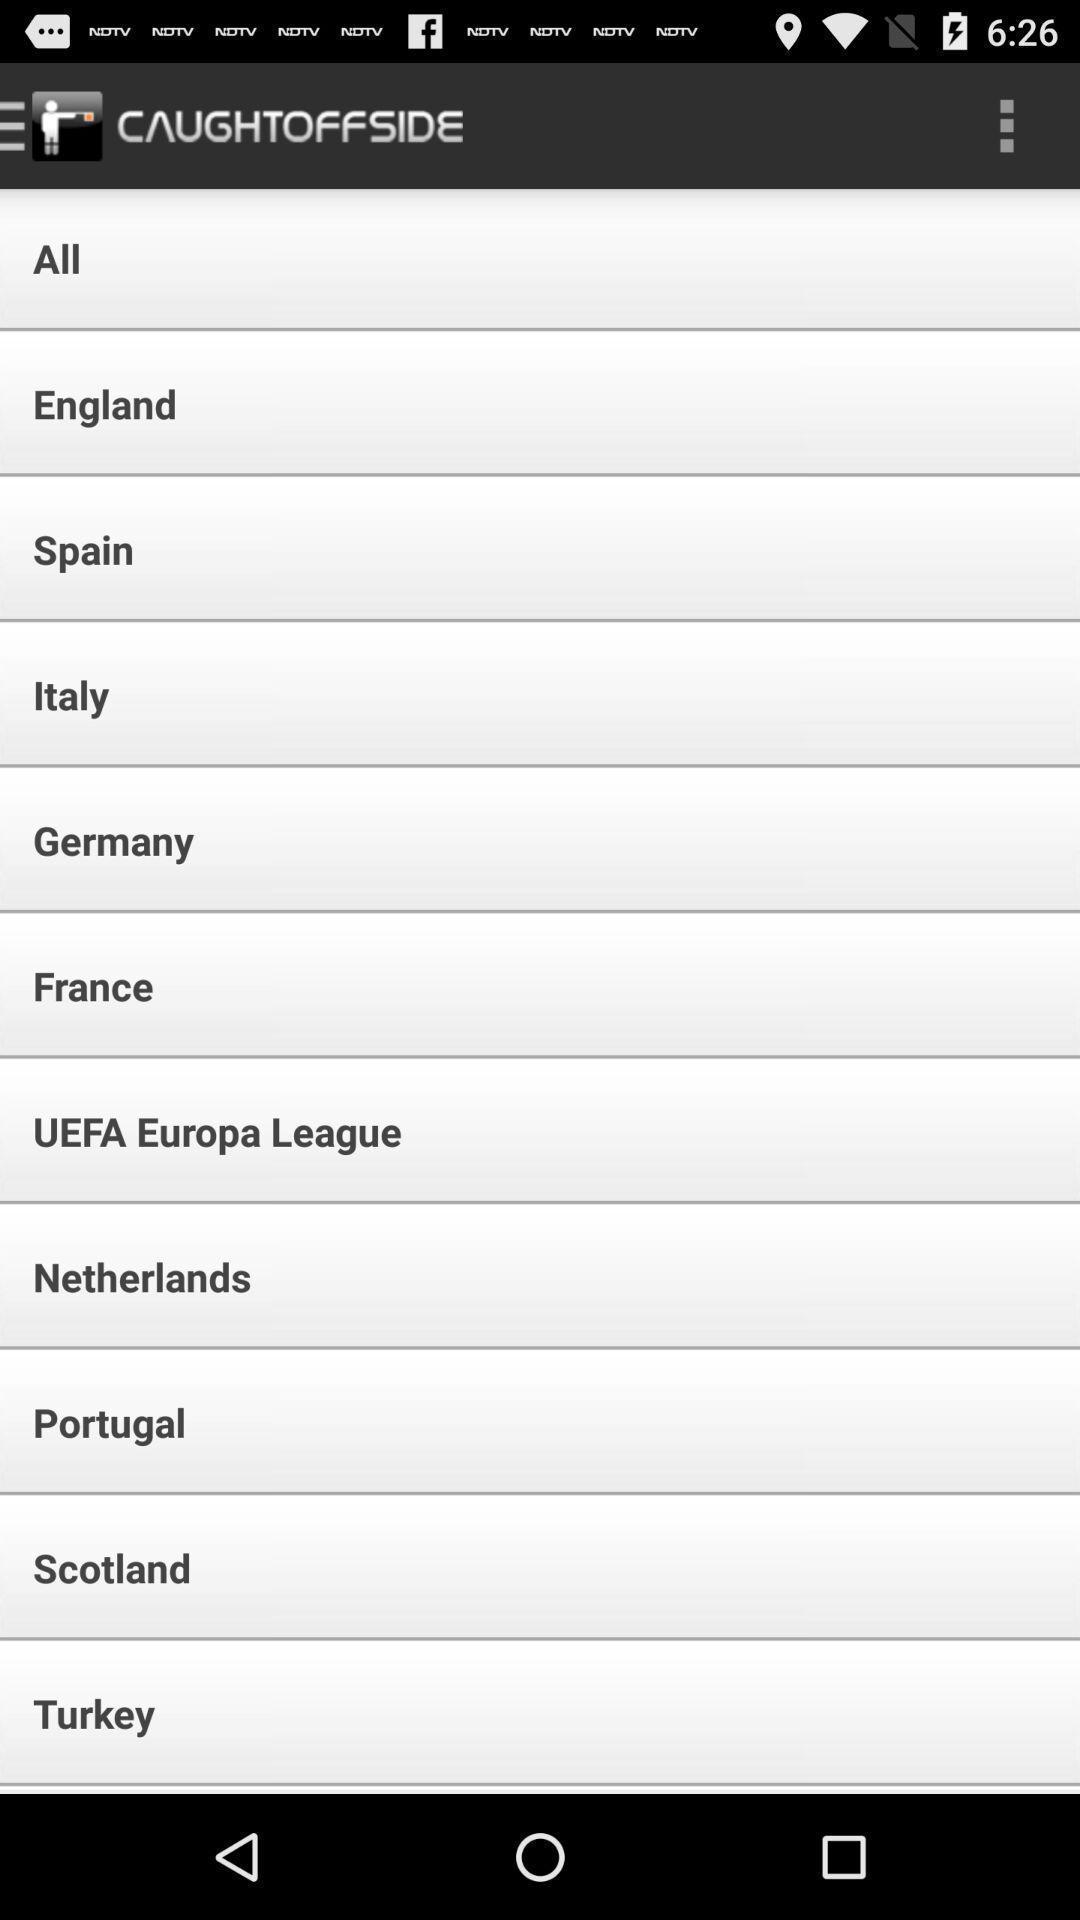Explain the elements present in this screenshot. Page displaying with list of different countries. 